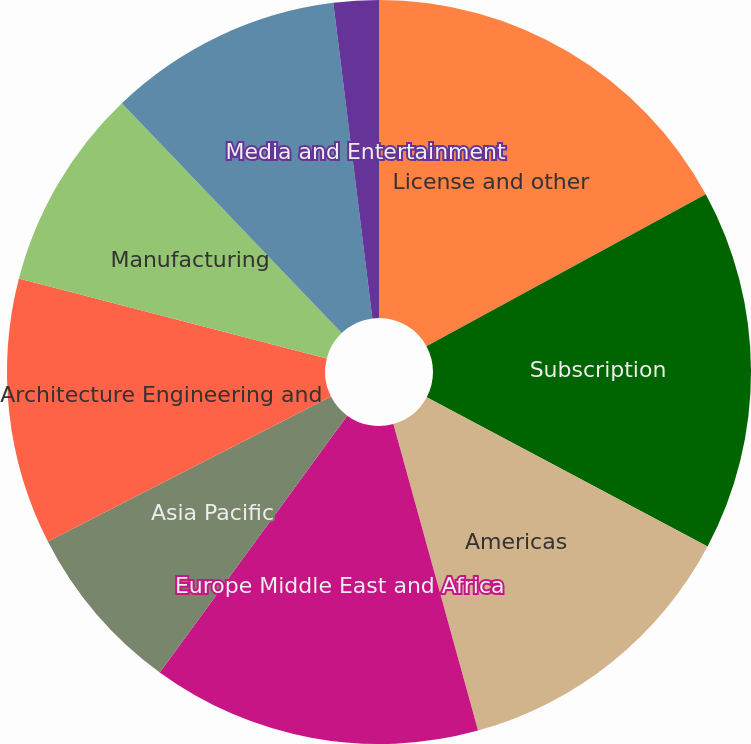Convert chart. <chart><loc_0><loc_0><loc_500><loc_500><pie_chart><fcel>License and other<fcel>Subscription<fcel>Americas<fcel>Europe Middle East and Africa<fcel>Asia Pacific<fcel>Architecture Engineering and<fcel>Manufacturing<fcel>Platform Solutions and<fcel>Media and Entertainment<nl><fcel>17.07%<fcel>15.7%<fcel>12.94%<fcel>14.32%<fcel>7.44%<fcel>11.57%<fcel>8.81%<fcel>10.19%<fcel>1.96%<nl></chart> 